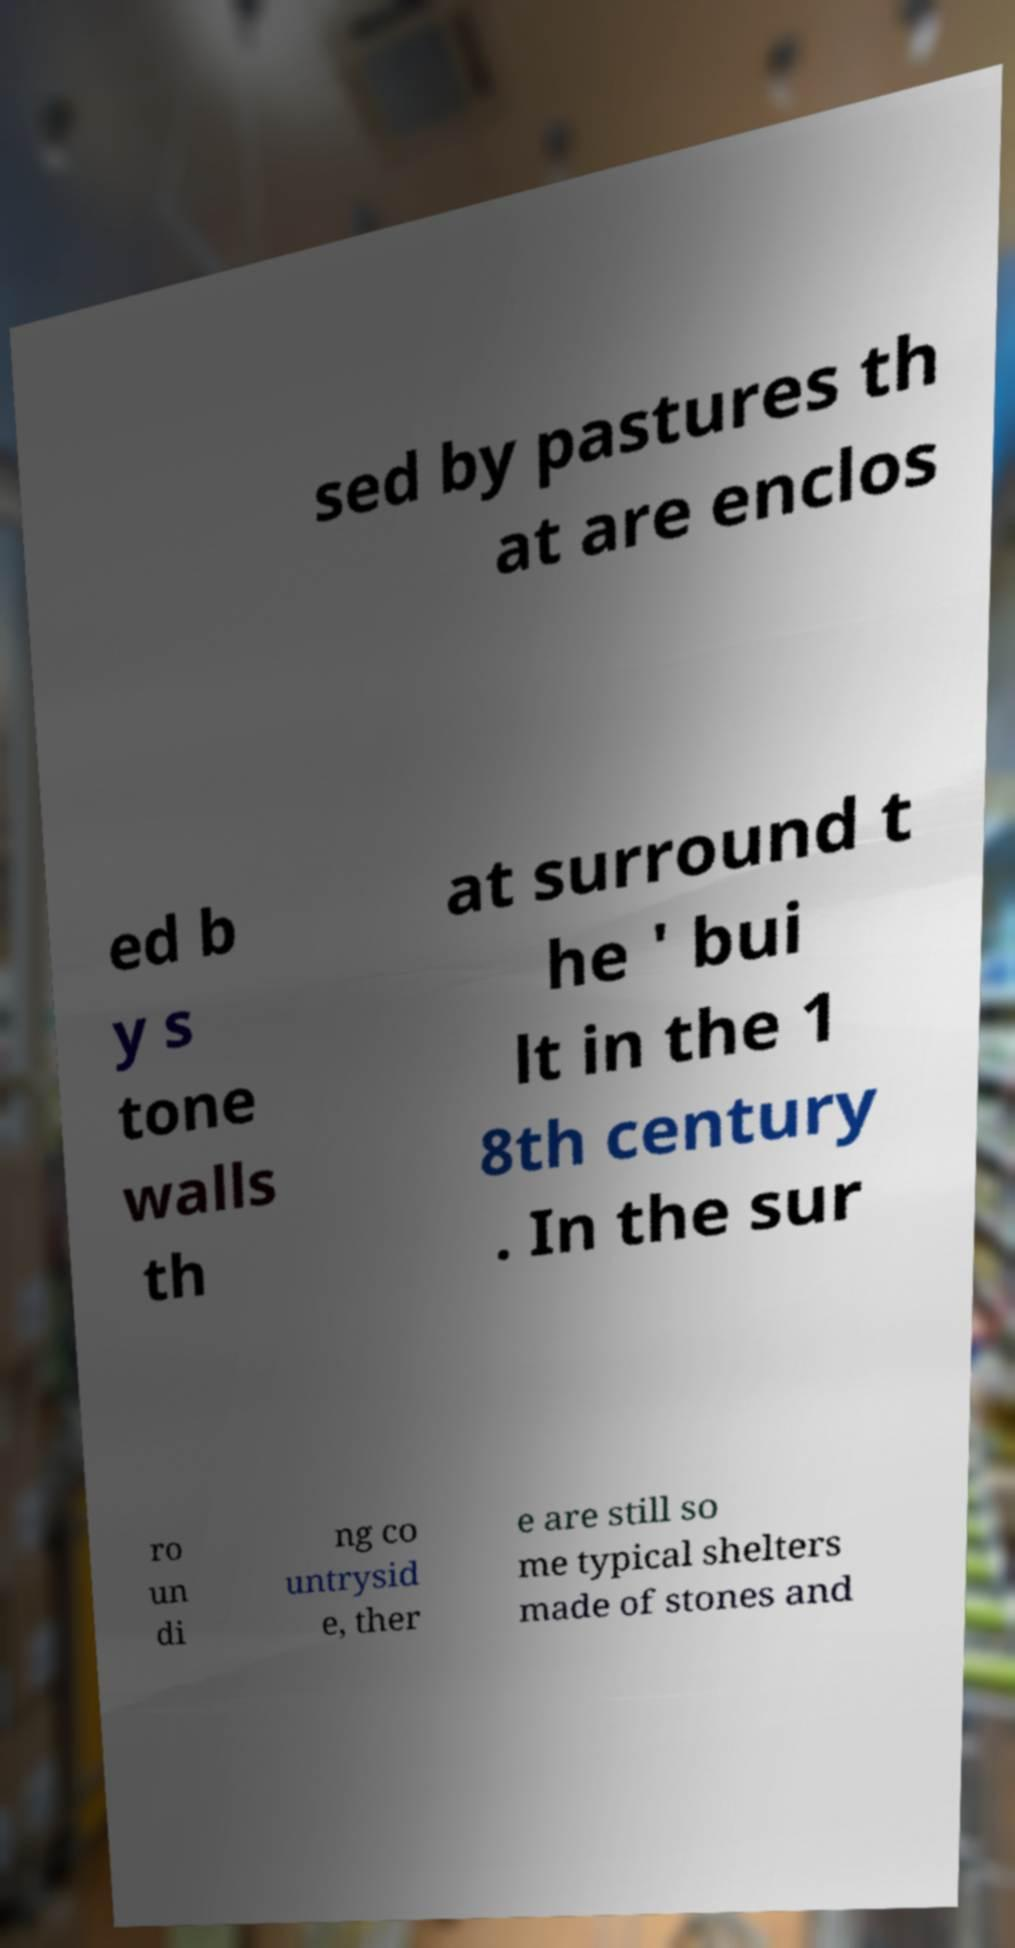Could you assist in decoding the text presented in this image and type it out clearly? sed by pastures th at are enclos ed b y s tone walls th at surround t he ' bui lt in the 1 8th century . In the sur ro un di ng co untrysid e, ther e are still so me typical shelters made of stones and 